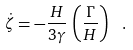Convert formula to latex. <formula><loc_0><loc_0><loc_500><loc_500>\dot { \zeta } = - \frac { H } { 3 \gamma } \, \left ( \frac { \Gamma } { H } \right ) ^ { } \ .</formula> 